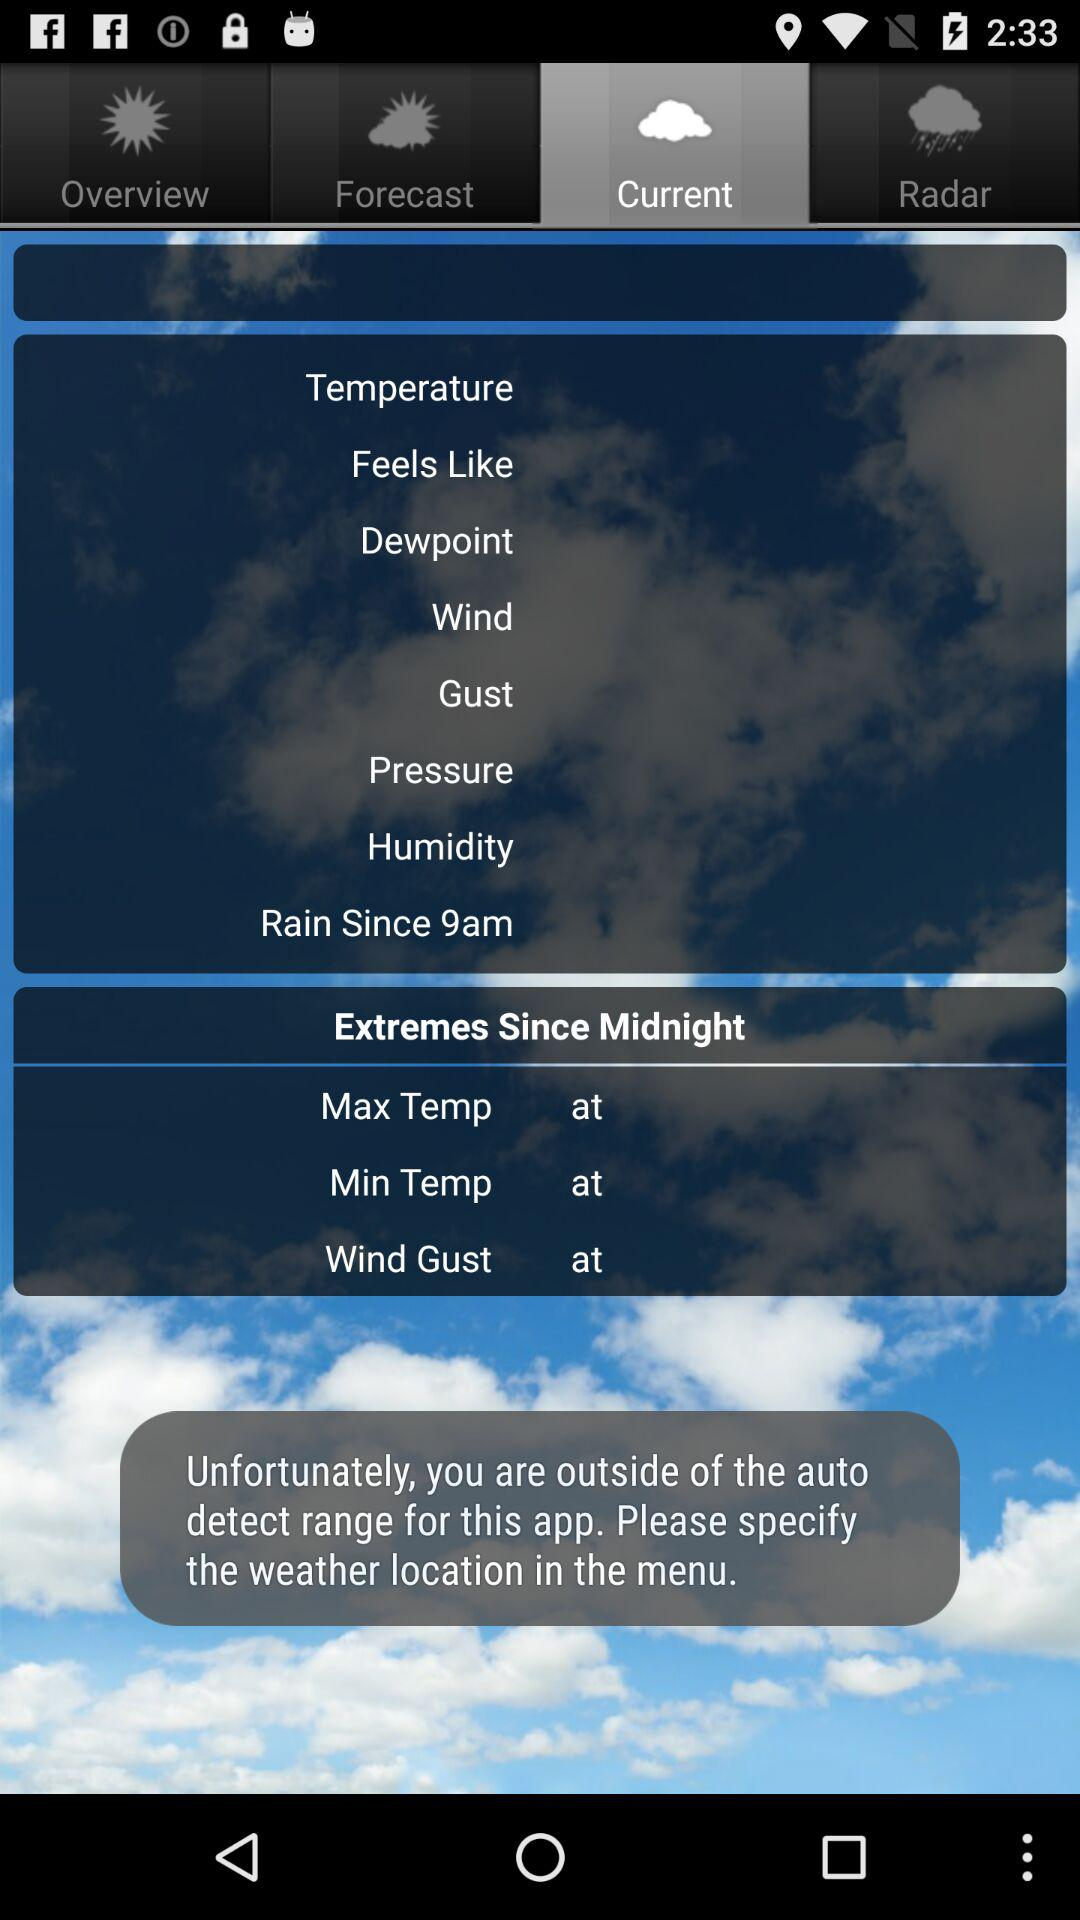How many notifications are there in "Radar"?
When the provided information is insufficient, respond with <no answer>. <no answer> 